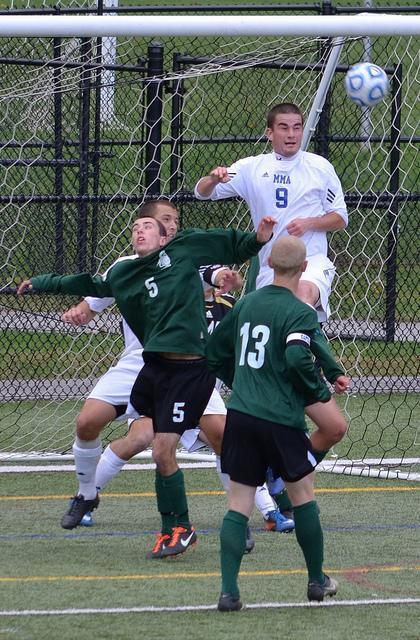How many people are in the photo?
Give a very brief answer. 4. How many stickers have a picture of a dog on them?
Give a very brief answer. 0. 